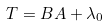Convert formula to latex. <formula><loc_0><loc_0><loc_500><loc_500>T = B A + \lambda _ { 0 }</formula> 